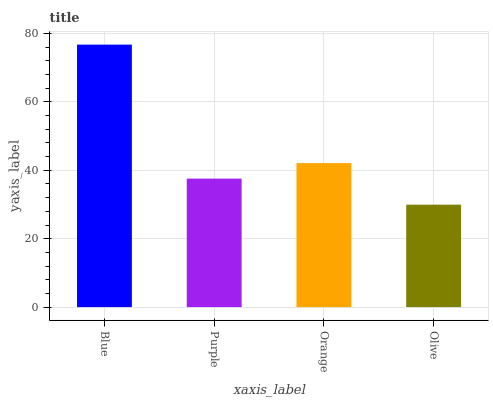Is Olive the minimum?
Answer yes or no. Yes. Is Blue the maximum?
Answer yes or no. Yes. Is Purple the minimum?
Answer yes or no. No. Is Purple the maximum?
Answer yes or no. No. Is Blue greater than Purple?
Answer yes or no. Yes. Is Purple less than Blue?
Answer yes or no. Yes. Is Purple greater than Blue?
Answer yes or no. No. Is Blue less than Purple?
Answer yes or no. No. Is Orange the high median?
Answer yes or no. Yes. Is Purple the low median?
Answer yes or no. Yes. Is Purple the high median?
Answer yes or no. No. Is Olive the low median?
Answer yes or no. No. 